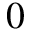<formula> <loc_0><loc_0><loc_500><loc_500>0</formula> 